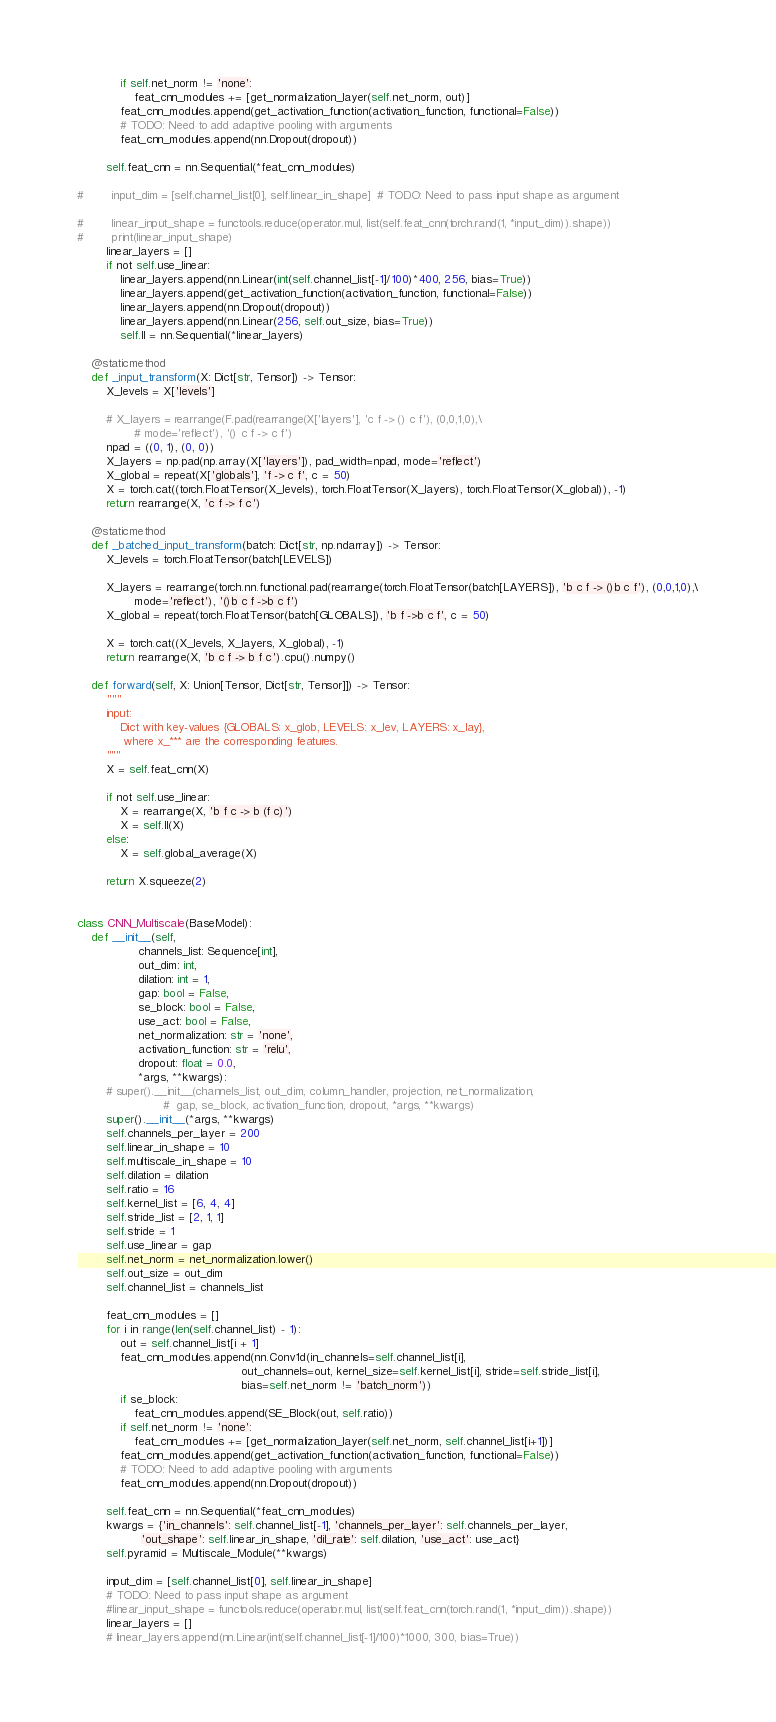<code> <loc_0><loc_0><loc_500><loc_500><_Python_>            if self.net_norm != 'none':
                feat_cnn_modules += [get_normalization_layer(self.net_norm, out)]
            feat_cnn_modules.append(get_activation_function(activation_function, functional=False))
            # TODO: Need to add adaptive pooling with arguments
            feat_cnn_modules.append(nn.Dropout(dropout))

        self.feat_cnn = nn.Sequential(*feat_cnn_modules)

#        input_dim = [self.channel_list[0], self.linear_in_shape]  # TODO: Need to pass input shape as argument

#        linear_input_shape = functools.reduce(operator.mul, list(self.feat_cnn(torch.rand(1, *input_dim)).shape))
#        print(linear_input_shape)
        linear_layers = []
        if not self.use_linear:
            linear_layers.append(nn.Linear(int(self.channel_list[-1]/100)*400, 256, bias=True))
            linear_layers.append(get_activation_function(activation_function, functional=False))
            linear_layers.append(nn.Dropout(dropout))
            linear_layers.append(nn.Linear(256, self.out_size, bias=True))
            self.ll = nn.Sequential(*linear_layers)

    @staticmethod
    def _input_transform(X: Dict[str, Tensor]) -> Tensor:
        X_levels = X['levels']

        # X_layers = rearrange(F.pad(rearrange(X['layers'], 'c f -> () c f'), (0,0,1,0),\
                # mode='reflect'), '() c f -> c f')
        npad = ((0, 1), (0, 0))
        X_layers = np.pad(np.array(X['layers']), pad_width=npad, mode='reflect')
        X_global = repeat(X['globals'], 'f -> c f', c = 50)
        X = torch.cat((torch.FloatTensor(X_levels), torch.FloatTensor(X_layers), torch.FloatTensor(X_global)), -1)
        return rearrange(X, 'c f -> f c')

    @staticmethod
    def _batched_input_transform(batch: Dict[str, np.ndarray]) -> Tensor:
        X_levels = torch.FloatTensor(batch[LEVELS])

        X_layers = rearrange(torch.nn.functional.pad(rearrange(torch.FloatTensor(batch[LAYERS]), 'b c f -> ()b c f'), (0,0,1,0),\
                mode='reflect'), '()b c f ->b c f')
        X_global = repeat(torch.FloatTensor(batch[GLOBALS]), 'b f ->b c f', c = 50)

        X = torch.cat((X_levels, X_layers, X_global), -1)
        return rearrange(X, 'b c f -> b f c').cpu().numpy()

    def forward(self, X: Union[Tensor, Dict[str, Tensor]]) -> Tensor:
        """
        input:
            Dict with key-values {GLOBALS: x_glob, LEVELS: x_lev, LAYERS: x_lay},
             where x_*** are the corresponding features.
        """ 
        X = self.feat_cnn(X)

        if not self.use_linear:
            X = rearrange(X, 'b f c -> b (f c)')
            X = self.ll(X)
        else:
            X = self.global_average(X)

        return X.squeeze(2)


class CNN_Multiscale(BaseModel):
    def __init__(self,
                 channels_list: Sequence[int],
                 out_dim: int,
                 dilation: int = 1,
                 gap: bool = False,
                 se_block: bool = False,
                 use_act: bool = False,
                 net_normalization: str = 'none',
                 activation_function: str = 'relu',
                 dropout: float = 0.0,
                 *args, **kwargs):
        # super().__init__(channels_list, out_dim, column_handler, projection, net_normalization,
                        #  gap, se_block, activation_function, dropout, *args, **kwargs)
        super().__init__(*args, **kwargs)
        self.channels_per_layer = 200
        self.linear_in_shape = 10
        self.multiscale_in_shape = 10
        self.dilation = dilation
        self.ratio = 16
        self.kernel_list = [6, 4, 4]
        self.stride_list = [2, 1, 1]
        self.stride = 1
        self.use_linear = gap
        self.net_norm = net_normalization.lower()
        self.out_size = out_dim
        self.channel_list = channels_list

        feat_cnn_modules = []
        for i in range(len(self.channel_list) - 1):
            out = self.channel_list[i + 1]
            feat_cnn_modules.append(nn.Conv1d(in_channels=self.channel_list[i],
                                              out_channels=out, kernel_size=self.kernel_list[i], stride=self.stride_list[i],
                                              bias=self.net_norm != 'batch_norm'))
            if se_block:
                feat_cnn_modules.append(SE_Block(out, self.ratio))
            if self.net_norm != 'none':
                feat_cnn_modules += [get_normalization_layer(self.net_norm, self.channel_list[i+1])]
            feat_cnn_modules.append(get_activation_function(activation_function, functional=False))
            # TODO: Need to add adaptive pooling with arguments
            feat_cnn_modules.append(nn.Dropout(dropout))

        self.feat_cnn = nn.Sequential(*feat_cnn_modules)
        kwargs = {'in_channels': self.channel_list[-1], 'channels_per_layer': self.channels_per_layer,
                  'out_shape': self.linear_in_shape, 'dil_rate': self.dilation, 'use_act': use_act}
        self.pyramid = Multiscale_Module(**kwargs)

        input_dim = [self.channel_list[0], self.linear_in_shape]
        # TODO: Need to pass input shape as argument
        #linear_input_shape = functools.reduce(operator.mul, list(self.feat_cnn(torch.rand(1, *input_dim)).shape))
        linear_layers = []
        # linear_layers.append(nn.Linear(int(self.channel_list[-1]/100)*1000, 300, bias=True))</code> 